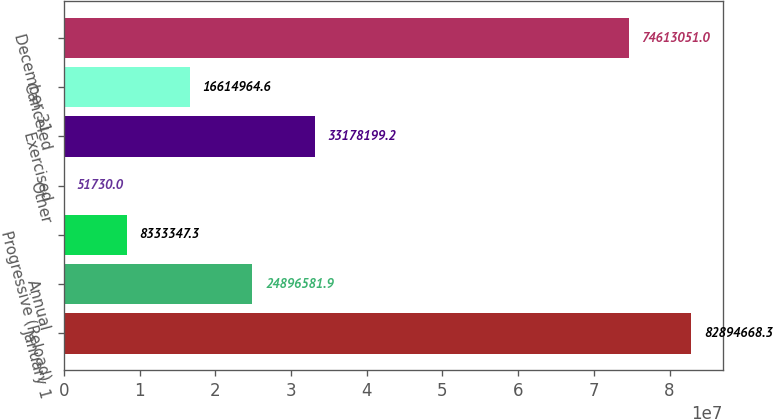Convert chart to OTSL. <chart><loc_0><loc_0><loc_500><loc_500><bar_chart><fcel>January 1<fcel>Annual<fcel>Progressive (Reload)<fcel>Other<fcel>Exercised<fcel>Canceled<fcel>December 31<nl><fcel>8.28947e+07<fcel>2.48966e+07<fcel>8.33335e+06<fcel>51730<fcel>3.31782e+07<fcel>1.6615e+07<fcel>7.46131e+07<nl></chart> 